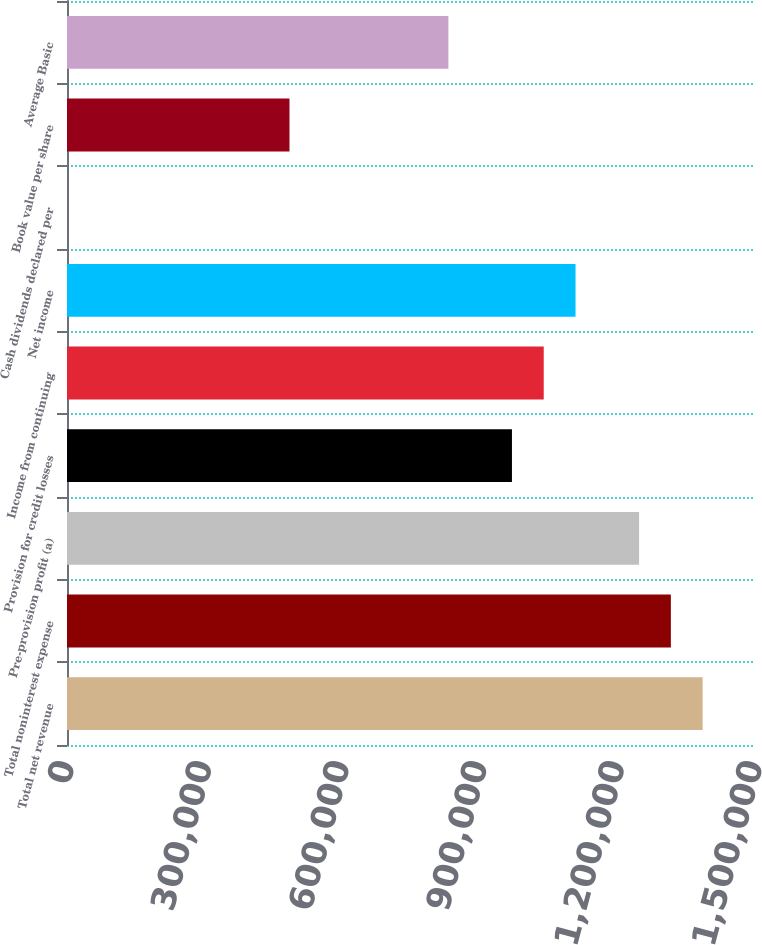Convert chart. <chart><loc_0><loc_0><loc_500><loc_500><bar_chart><fcel>Total net revenue<fcel>Total noninterest expense<fcel>Pre-provision profit (a)<fcel>Provision for credit losses<fcel>Income from continuing<fcel>Net income<fcel>Cash dividends declared per<fcel>Book value per share<fcel>Average Basic<nl><fcel>1.38585e+06<fcel>1.31656e+06<fcel>1.24727e+06<fcel>970098<fcel>1.03939e+06<fcel>1.10868e+06<fcel>0.2<fcel>485049<fcel>831512<nl></chart> 